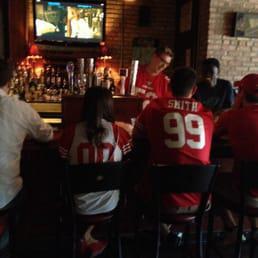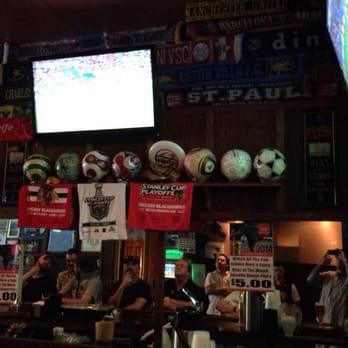The first image is the image on the left, the second image is the image on the right. Analyze the images presented: Is the assertion "There are televisions in exactly one of the imagtes." valid? Answer yes or no. No. The first image is the image on the left, the second image is the image on the right. Given the left and right images, does the statement "In at least one image there are three people at the bar looking at a television." hold true? Answer yes or no. Yes. 